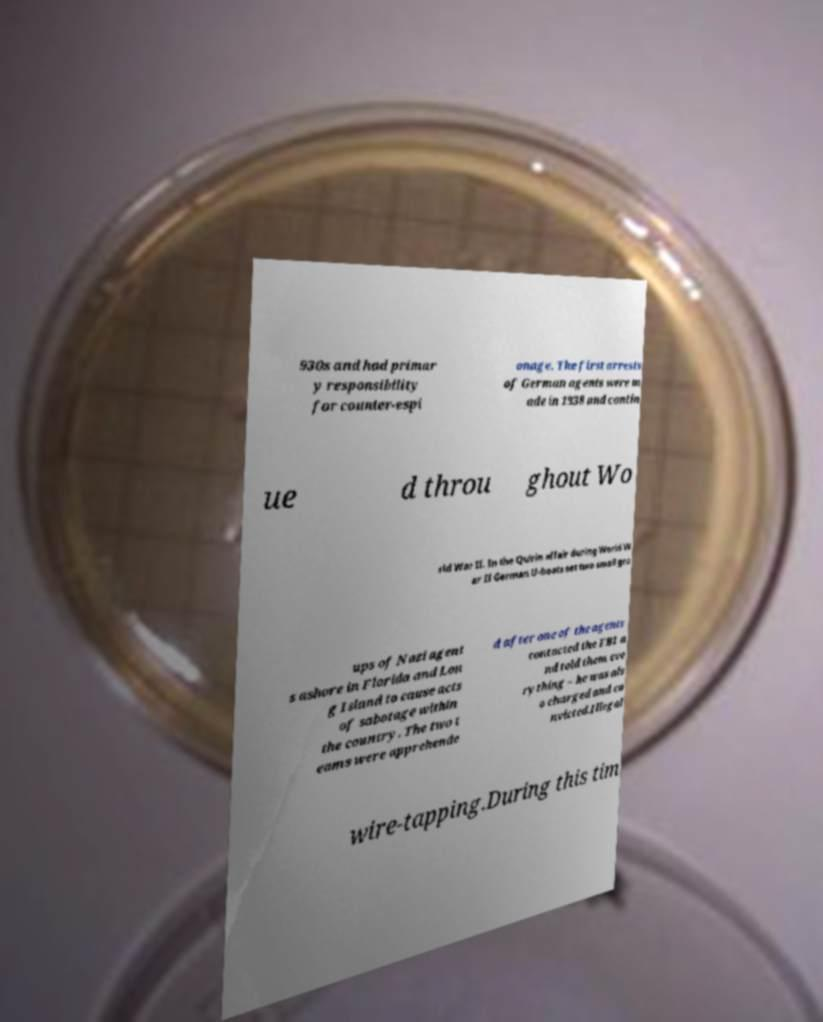Could you extract and type out the text from this image? 930s and had primar y responsibility for counter-espi onage. The first arrests of German agents were m ade in 1938 and contin ue d throu ghout Wo rld War II. In the Quirin affair during World W ar II German U-boats set two small gro ups of Nazi agent s ashore in Florida and Lon g Island to cause acts of sabotage within the country. The two t eams were apprehende d after one of the agents contacted the FBI a nd told them eve rything – he was als o charged and co nvicted.Illegal wire-tapping.During this tim 